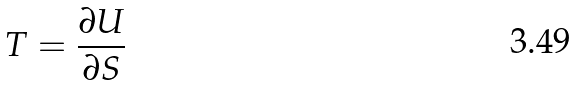Convert formula to latex. <formula><loc_0><loc_0><loc_500><loc_500>T = \frac { \partial U } { \partial S }</formula> 